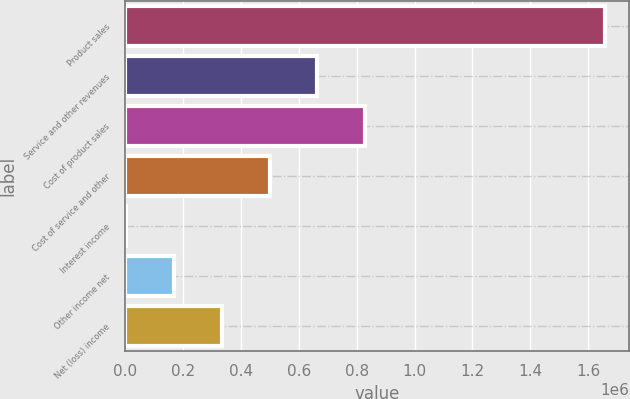Convert chart. <chart><loc_0><loc_0><loc_500><loc_500><bar_chart><fcel>Product sales<fcel>Service and other revenues<fcel>Cost of product sales<fcel>Cost of service and other<fcel>Interest income<fcel>Other income net<fcel>Net (loss) income<nl><fcel>1.65773e+06<fcel>664495<fcel>830034<fcel>498956<fcel>2340<fcel>167879<fcel>333418<nl></chart> 